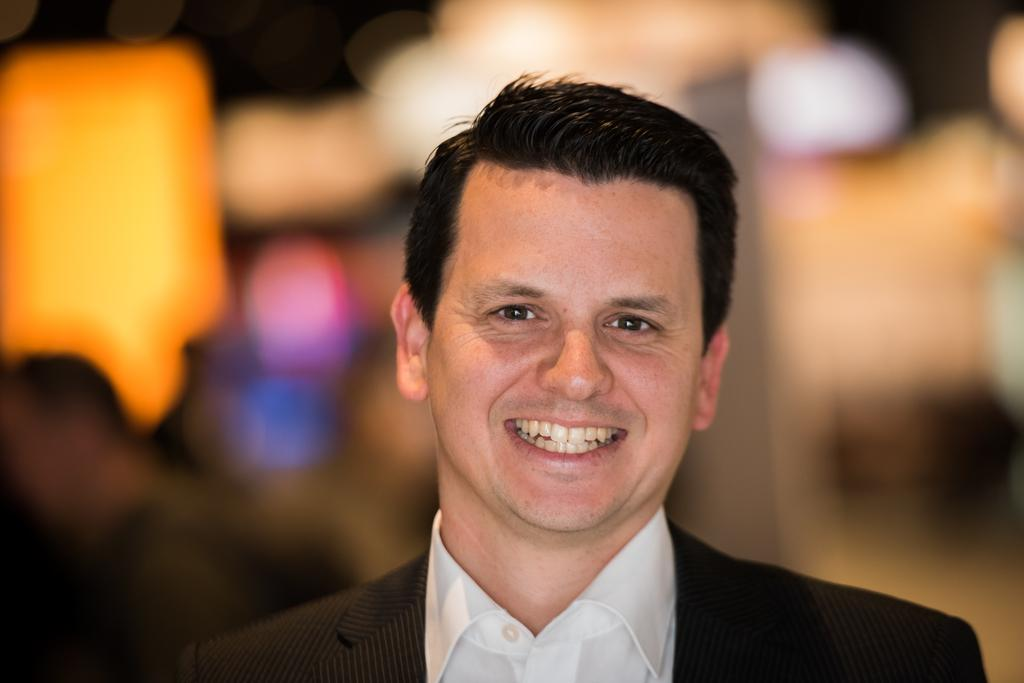Who is in the image? There is a man in the image. What is the man doing in the image? The man is posing for a photo. How is the man's expression in the image? The man is smiling in the image. What can be observed about the background in the image? The background of the man is blurred. What book is the man reading in the alley in the image? There is no book or alley present in the image; it features a man posing for a photo with a blurred background. 